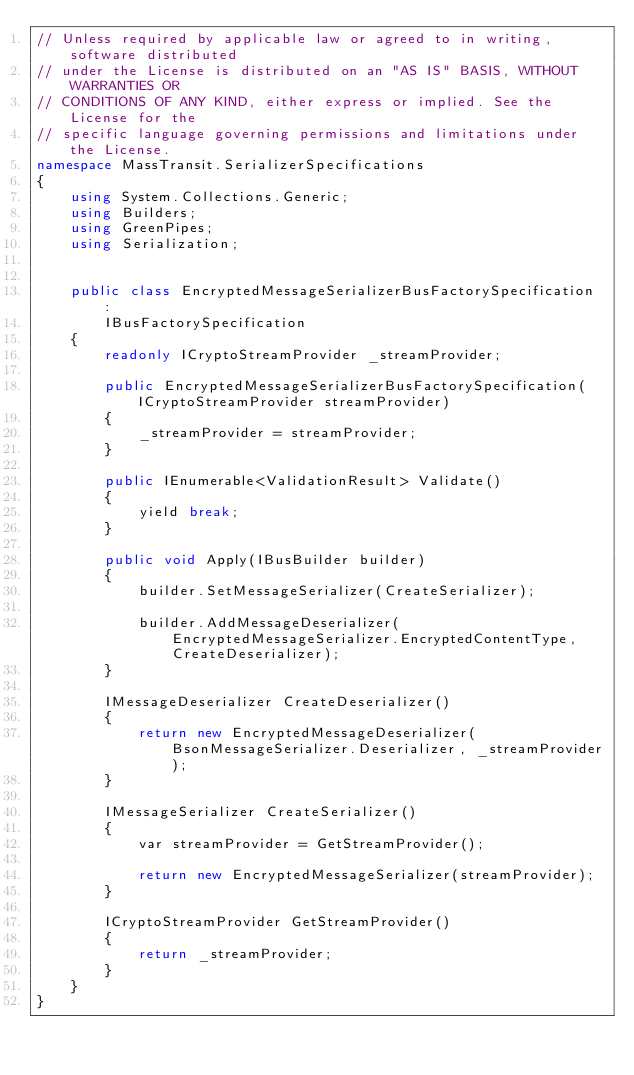<code> <loc_0><loc_0><loc_500><loc_500><_C#_>// Unless required by applicable law or agreed to in writing, software distributed
// under the License is distributed on an "AS IS" BASIS, WITHOUT WARRANTIES OR 
// CONDITIONS OF ANY KIND, either express or implied. See the License for the 
// specific language governing permissions and limitations under the License.
namespace MassTransit.SerializerSpecifications
{
    using System.Collections.Generic;
    using Builders;
    using GreenPipes;
    using Serialization;


    public class EncryptedMessageSerializerBusFactorySpecification :
        IBusFactorySpecification
    {
        readonly ICryptoStreamProvider _streamProvider;

        public EncryptedMessageSerializerBusFactorySpecification(ICryptoStreamProvider streamProvider)
        {
            _streamProvider = streamProvider;
        }

        public IEnumerable<ValidationResult> Validate()
        {
            yield break;
        }

        public void Apply(IBusBuilder builder)
        {
            builder.SetMessageSerializer(CreateSerializer);

            builder.AddMessageDeserializer(EncryptedMessageSerializer.EncryptedContentType, CreateDeserializer);
        }

        IMessageDeserializer CreateDeserializer()
        {
            return new EncryptedMessageDeserializer(BsonMessageSerializer.Deserializer, _streamProvider);
        }

        IMessageSerializer CreateSerializer()
        {
            var streamProvider = GetStreamProvider();

            return new EncryptedMessageSerializer(streamProvider);
        }

        ICryptoStreamProvider GetStreamProvider()
        {
            return _streamProvider;
        }
    }
}</code> 